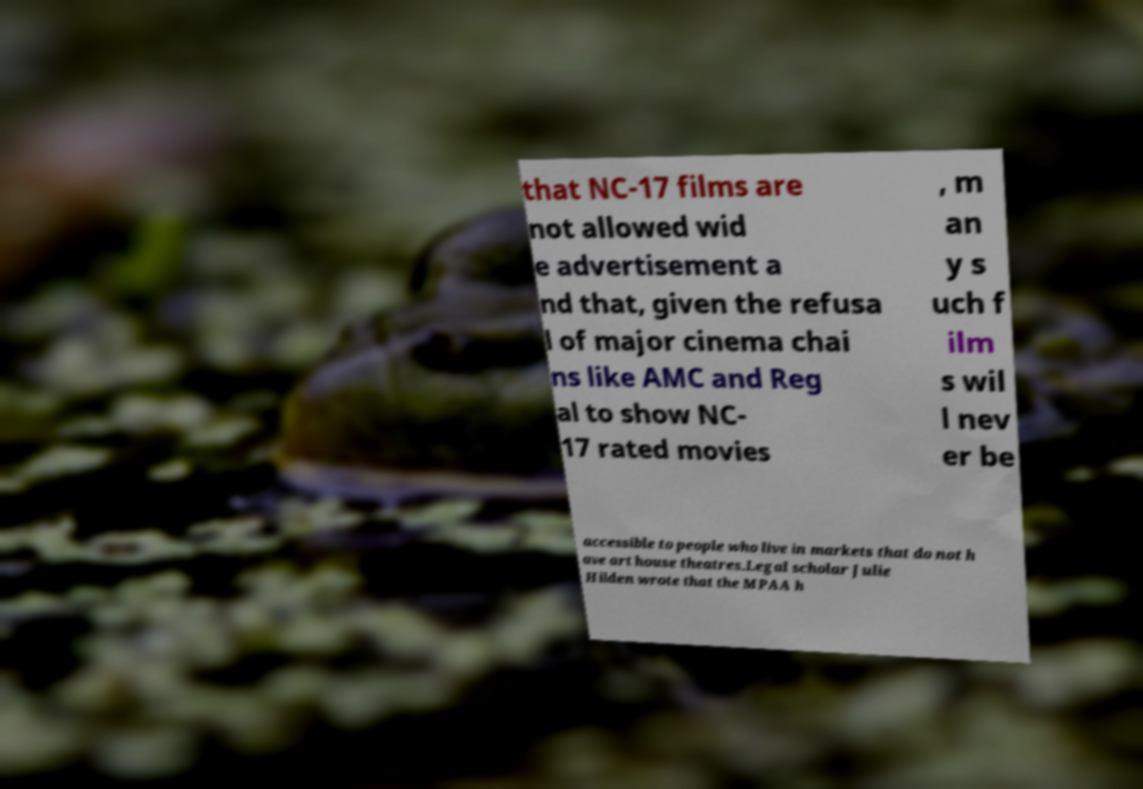Could you assist in decoding the text presented in this image and type it out clearly? that NC-17 films are not allowed wid e advertisement a nd that, given the refusa l of major cinema chai ns like AMC and Reg al to show NC- 17 rated movies , m an y s uch f ilm s wil l nev er be accessible to people who live in markets that do not h ave art house theatres.Legal scholar Julie Hilden wrote that the MPAA h 